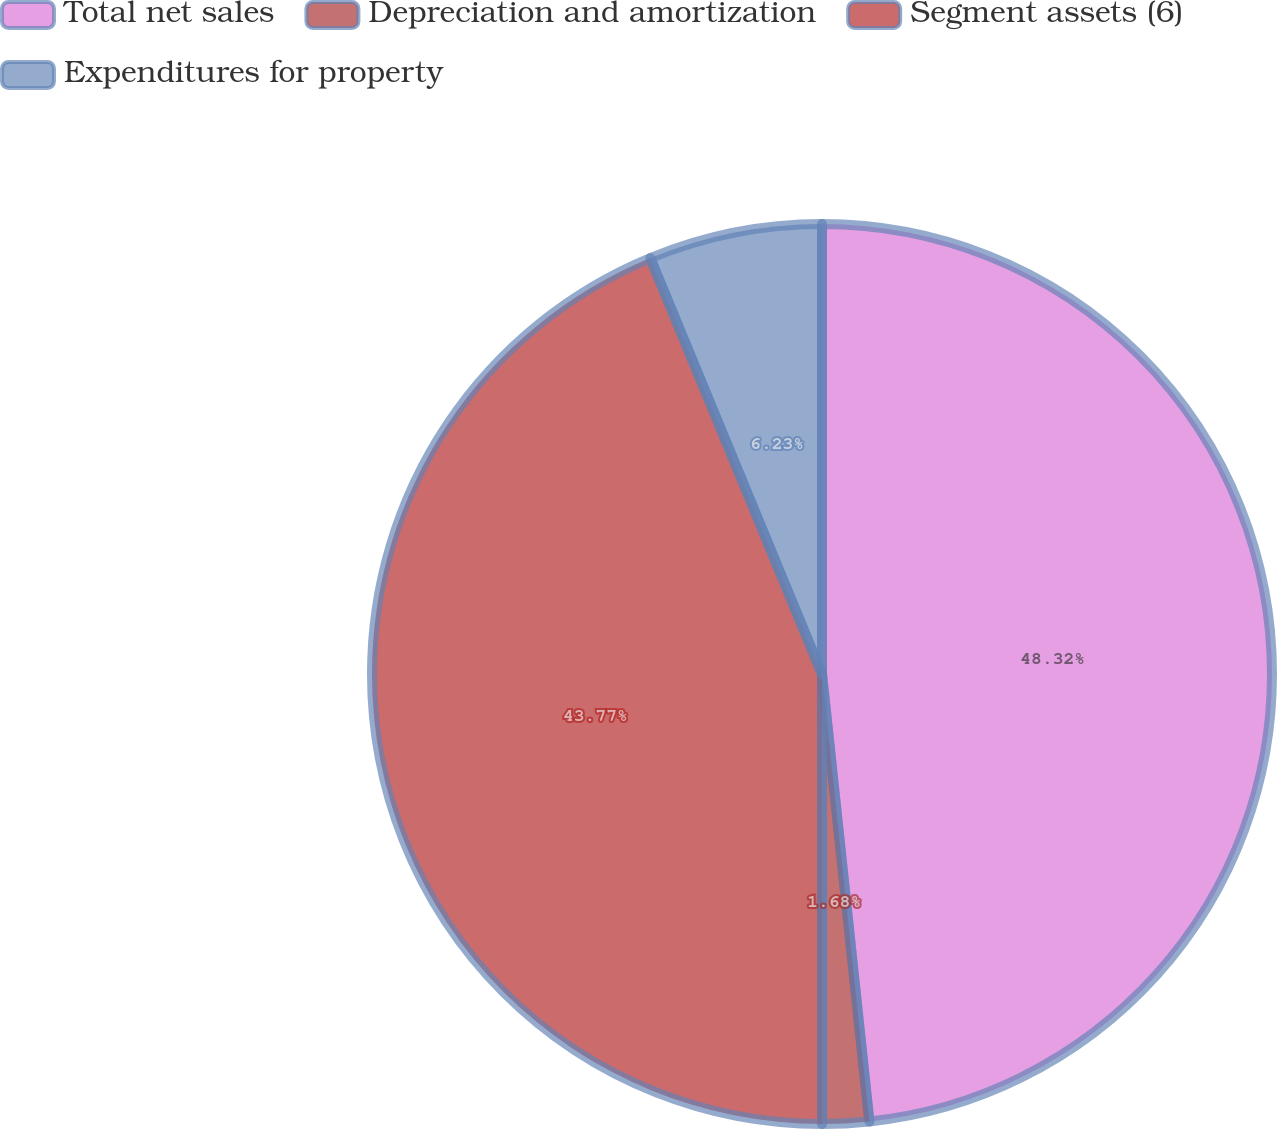Convert chart to OTSL. <chart><loc_0><loc_0><loc_500><loc_500><pie_chart><fcel>Total net sales<fcel>Depreciation and amortization<fcel>Segment assets (6)<fcel>Expenditures for property<nl><fcel>48.32%<fcel>1.68%<fcel>43.77%<fcel>6.23%<nl></chart> 